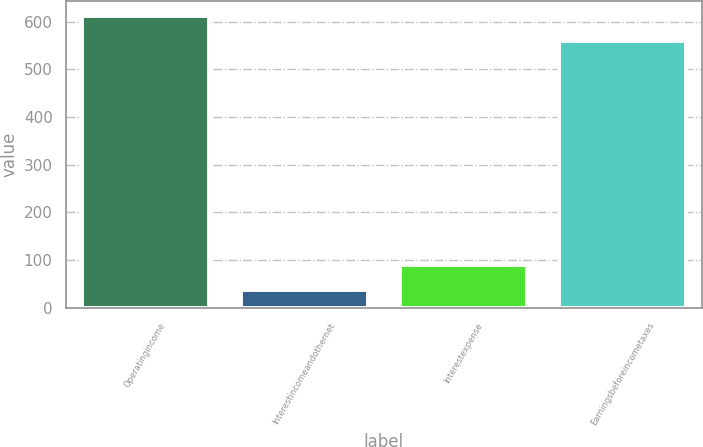<chart> <loc_0><loc_0><loc_500><loc_500><bar_chart><fcel>Operatingincome<fcel>Interestincomeandothernet<fcel>Interestexpense<fcel>Earningsbeforeincometaxes<nl><fcel>612.4<fcel>37<fcel>89.5<fcel>559.9<nl></chart> 